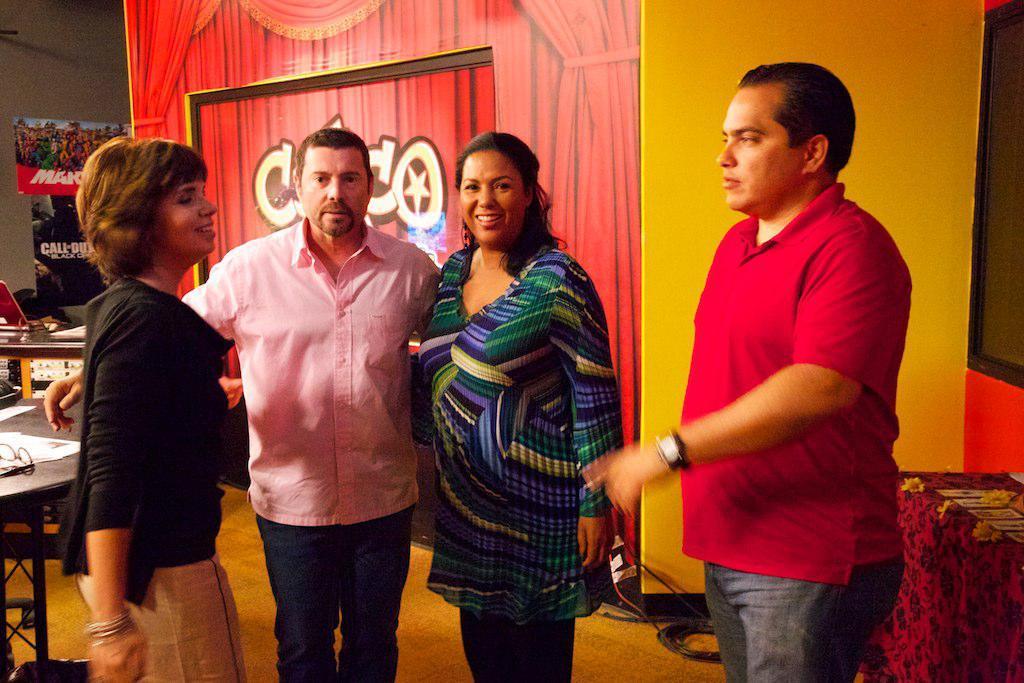Please provide a concise description of this image. In this image there are a few people standing with a smile on their face, behind them on the tables there are some objects. On the floor there are cables, in the background of the image there are display boards and walls. 